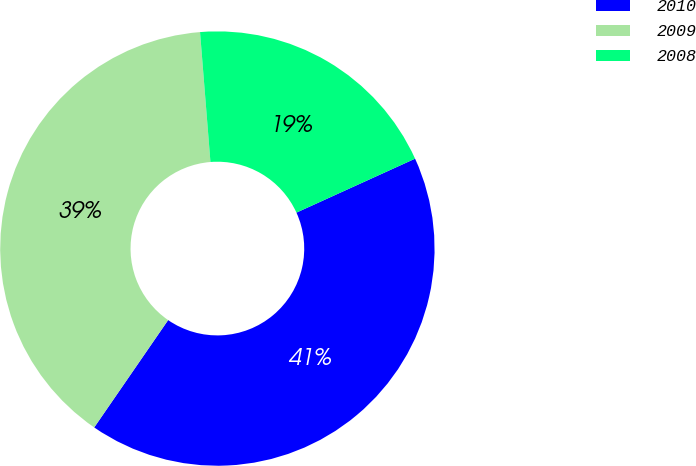Convert chart. <chart><loc_0><loc_0><loc_500><loc_500><pie_chart><fcel>2010<fcel>2009<fcel>2008<nl><fcel>41.39%<fcel>39.13%<fcel>19.48%<nl></chart> 